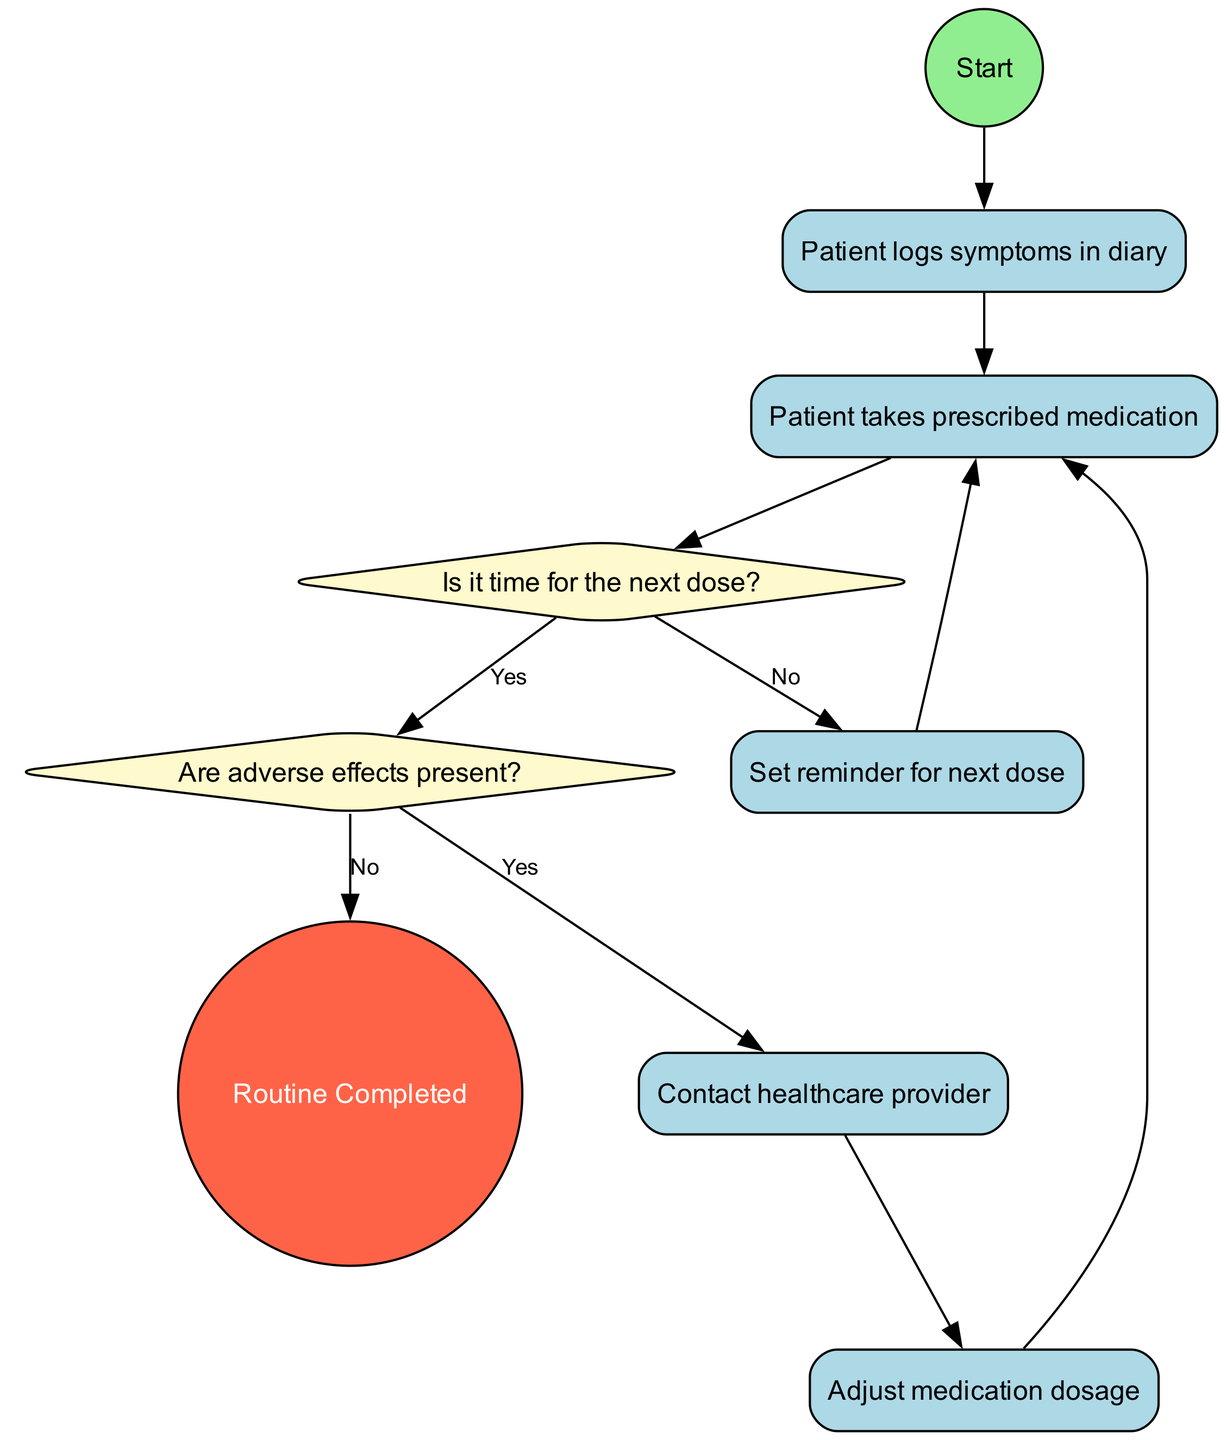What is the starting action in the routine? The first action node, labeled "Start," leads to "Patient logs symptoms in diary," making it the initial action in the routine.
Answer: Patient logs symptoms in diary How many decision nodes are present in the diagram? There are two decision nodes; one asks, "Is it time for the next dose?" and the other asks, "Are adverse effects present?"
Answer: 2 What action follows after the patient contacts the healthcare provider? After "Contact healthcare provider," the next action is "Adjust medication dosage," which is a subsequent step in the medication management routine.
Answer: Adjust medication dosage If the answer to "Are adverse effects present?" is no, what is the next step? If "Are adverse effects present?" is answered with "No," the routine moves directly to the end node, "Routine Completed," indicating no further actions are needed.
Answer: Routine Completed What condition prompts the patient to set a reminder? The condition leading to setting a reminder is when the answer to "Is it time for the next dose?" is "No," resulting in the action "Set reminder for next dose."
Answer: No What is the final step of the routine? The diagram concludes with the end node labeled "Routine Completed," which signifies the end of the medication management process.
Answer: Routine Completed Which action is immediately after the patient takes prescribed medication? The action that immediately follows "Patient takes prescribed medication" is "Is it time for the next dose?" which is a crucial decision point within the routine.
Answer: Is it time for the next dose? What happens if the patient adjusts their medication dosage? If the patient adjusts medication dosage, the routine returns to the action node "Patient takes prescribed medication," indicating the cycle continues with the updated medication.
Answer: Patient takes prescribed medication 